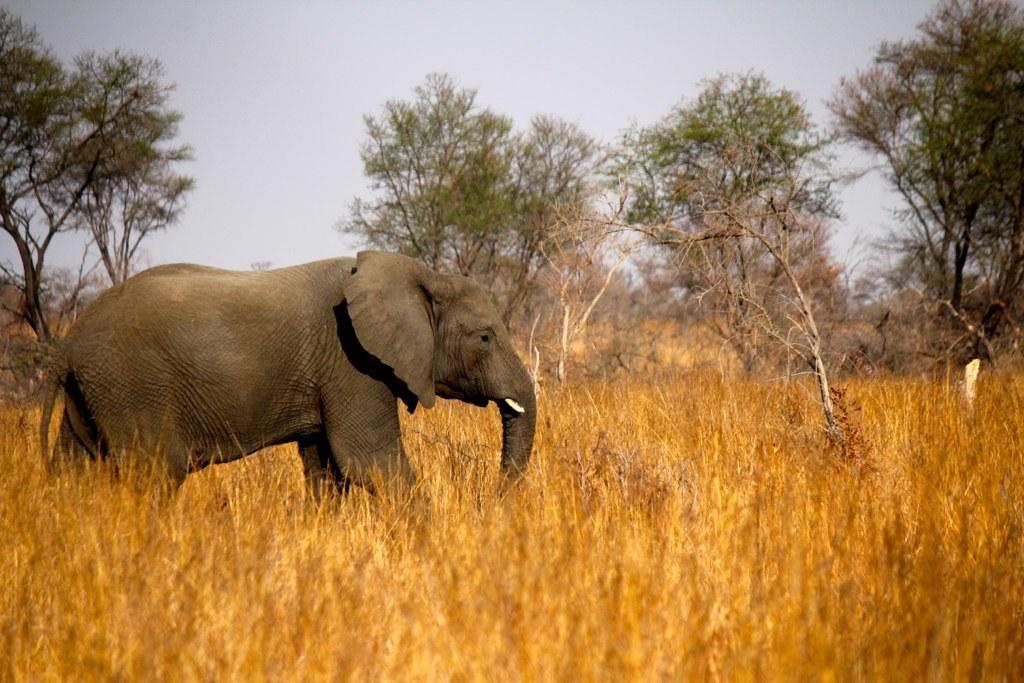How would you summarize this image in a sentence or two? As we can see elephant. The grass which is in golden color, Trees and the sky. 